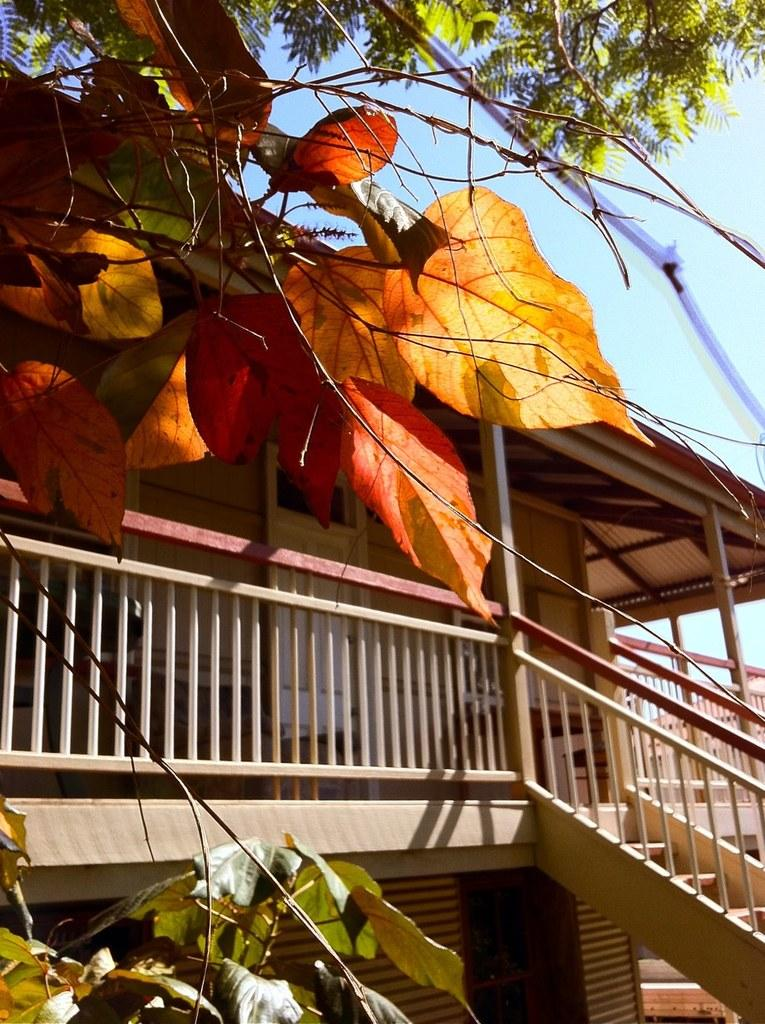What type of structure is visible in the image? There is a building in the image. What architectural feature can be seen in the image? There are stairs in the image. What type of vegetation is present in the image? There are trees in the image. What can be seen in the background of the image? The sky is visible in the background of the image. What time of day is it in the image, given the presence of a pear? There is no pear present in the image, so it is not possible to determine the time of day based on that information. 